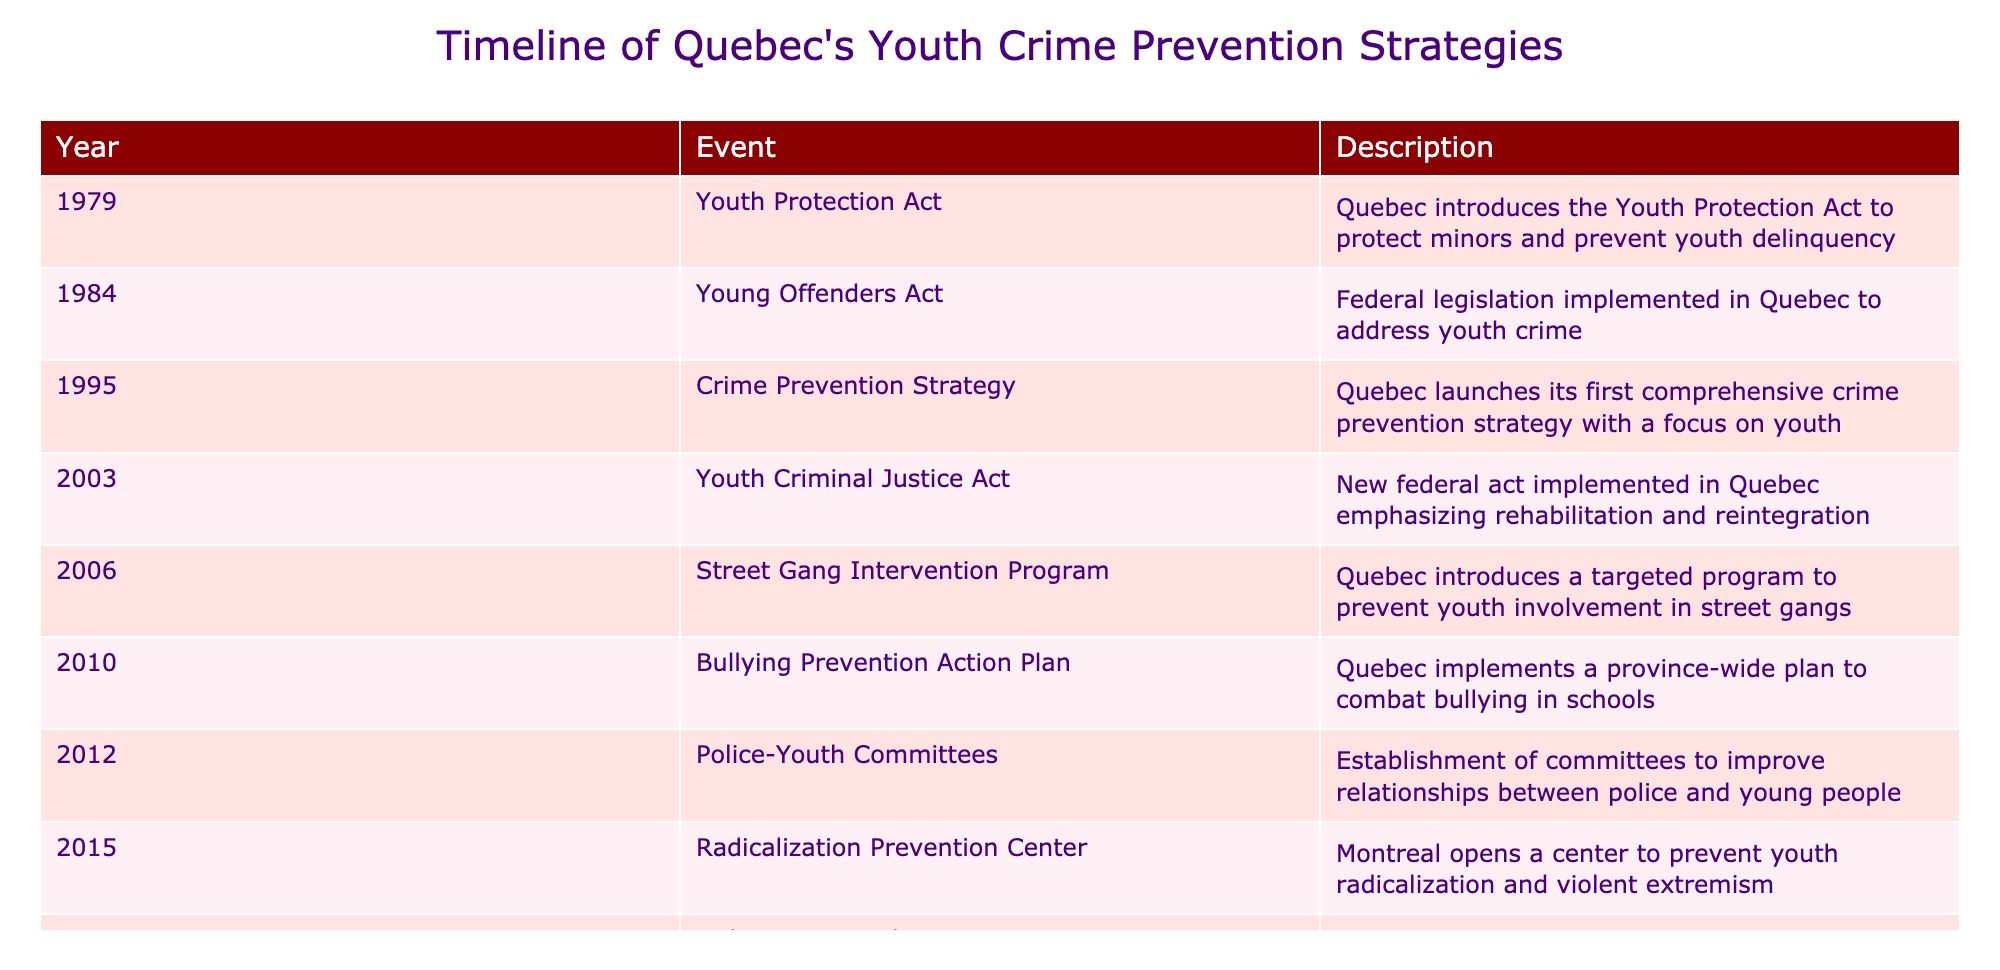What year was the Youth Protection Act introduced in Quebec? The table indicates that the Youth Protection Act was introduced in 1979. Therefore, the answer is straightforwardly found in the year column corresponding to that event.
Answer: 1979 What significant crime prevention strategy did Quebec launch in 1995? According to the table, the significant initiative launched in 1995 was the comprehensive Crime Prevention Strategy that primarily focused on youth. This is directly noted in the description for that year.
Answer: Crime Prevention Strategy How many years passed between the introduction of the Young Offenders Act and the Youth Criminal Justice Act? The Young Offenders Act was introduced in 1984 and the Youth Criminal Justice Act was introduced in 2003. By subtracting the years: 2003 - 1984 = 19, we can determine the number of years that passed between these two events.
Answer: 19 years Was the Radicalization Prevention Center opened before or after the Indigenous Youth Crime Prevention Initiative? The table shows that the Radicalization Prevention Center was opened in 2015, while the Indigenous Youth Crime Prevention Initiative was launched in 2017. Since 2015 comes before 2017, we conclude that the center was opened before the initiative.
Answer: Before How many total distinct prevention programs or strategies are listed in the timeline? By counting the unique events listed in the table, we find that there are 10 distinct events that represent various prevention strategies and legislative acts.
Answer: 10 What was a focus of the initiatives introduced between 2006 and 2019? Between 2006 and 2019, initiatives such as the Street Gang Intervention Program, Bullying Prevention Action Plan, Police-Youth Committees, Radicalization Prevention Center, Indigenous Youth Crime Prevention Initiative, and Cybercrime Prevention Strategy show a clear focus on preventing youth involvement in gangs, bullying, and online threats, emphasizing the importance of community and police engagement.
Answer: Gangs, bullying, cyber threats Which two strategies specifically target Indigenous youth? The timeline shows the establishment of the Indigenous Youth Crime Prevention Initiative in 2017, while earlier initiatives like the Youth Protection Act and the Crime Prevention Strategy do not explicitly target Indigenous youth. Therefore, the specific initiative here is the Indigenous Youth Crime Prevention Initiative itself.
Answer: Indigenous Youth Crime Prevention Initiative What was the focus of the 2010 Bullying Prevention Action Plan? The description for the 2010 event indicates that the Bullying Prevention Action Plan aimed to combat bullying in schools. Therefore, this strategy was clearly directed at addressing a critical issue affecting youth in the educational environment.
Answer: Combating bullying in schools What impact did the COVID-19 disruptions have on Quebec's youth crime strategies in 2021? The table specifies that in 2021, Quebec implemented the Post-Pandemic Youth Support Program to support at-risk youth in the aftermath of COVID-19 disruptions. This indicates that the pandemic negatively impacted youth, prompting the need for specialized support.
Answer: Support for at-risk youth due to COVID-19 disruptions 